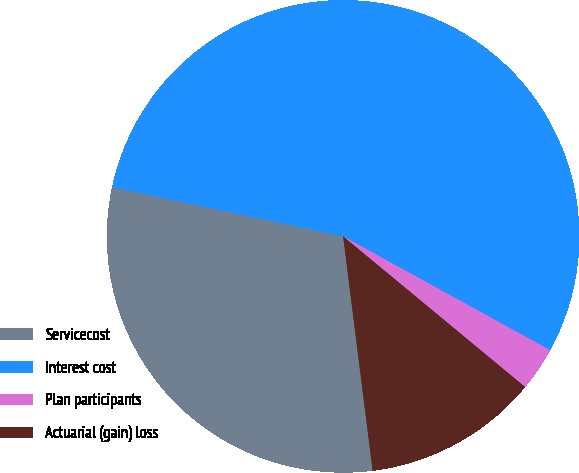Convert chart. <chart><loc_0><loc_0><loc_500><loc_500><pie_chart><fcel>Servicecost<fcel>Interest cost<fcel>Plan participants<fcel>Actuarial (gain) loss<nl><fcel>30.33%<fcel>54.67%<fcel>3.0%<fcel>12.0%<nl></chart> 